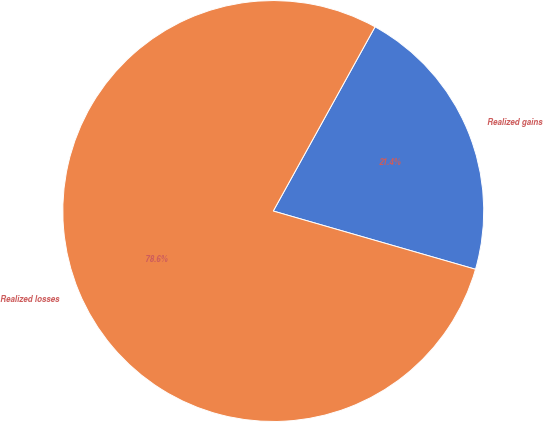Convert chart. <chart><loc_0><loc_0><loc_500><loc_500><pie_chart><fcel>Realized gains<fcel>Realized losses<nl><fcel>21.43%<fcel>78.57%<nl></chart> 